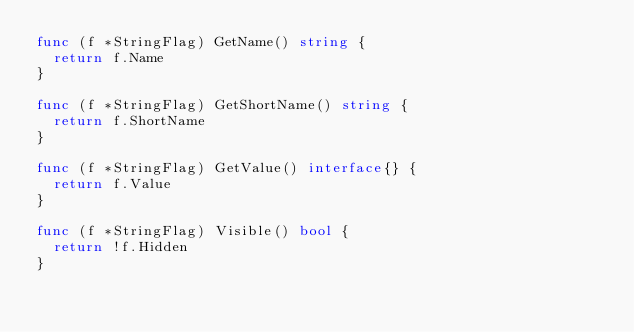Convert code to text. <code><loc_0><loc_0><loc_500><loc_500><_Go_>func (f *StringFlag) GetName() string {
	return f.Name
}

func (f *StringFlag) GetShortName() string {
	return f.ShortName
}

func (f *StringFlag) GetValue() interface{} {
	return f.Value
}

func (f *StringFlag) Visible() bool {
	return !f.Hidden
}
</code> 